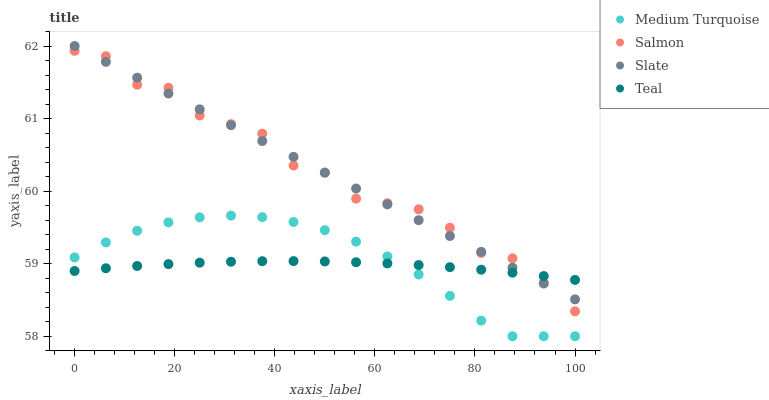Does Teal have the minimum area under the curve?
Answer yes or no. Yes. Does Salmon have the maximum area under the curve?
Answer yes or no. Yes. Does Salmon have the minimum area under the curve?
Answer yes or no. No. Does Teal have the maximum area under the curve?
Answer yes or no. No. Is Slate the smoothest?
Answer yes or no. Yes. Is Salmon the roughest?
Answer yes or no. Yes. Is Teal the smoothest?
Answer yes or no. No. Is Teal the roughest?
Answer yes or no. No. Does Medium Turquoise have the lowest value?
Answer yes or no. Yes. Does Salmon have the lowest value?
Answer yes or no. No. Does Slate have the highest value?
Answer yes or no. Yes. Does Salmon have the highest value?
Answer yes or no. No. Is Medium Turquoise less than Slate?
Answer yes or no. Yes. Is Salmon greater than Medium Turquoise?
Answer yes or no. Yes. Does Medium Turquoise intersect Teal?
Answer yes or no. Yes. Is Medium Turquoise less than Teal?
Answer yes or no. No. Is Medium Turquoise greater than Teal?
Answer yes or no. No. Does Medium Turquoise intersect Slate?
Answer yes or no. No. 